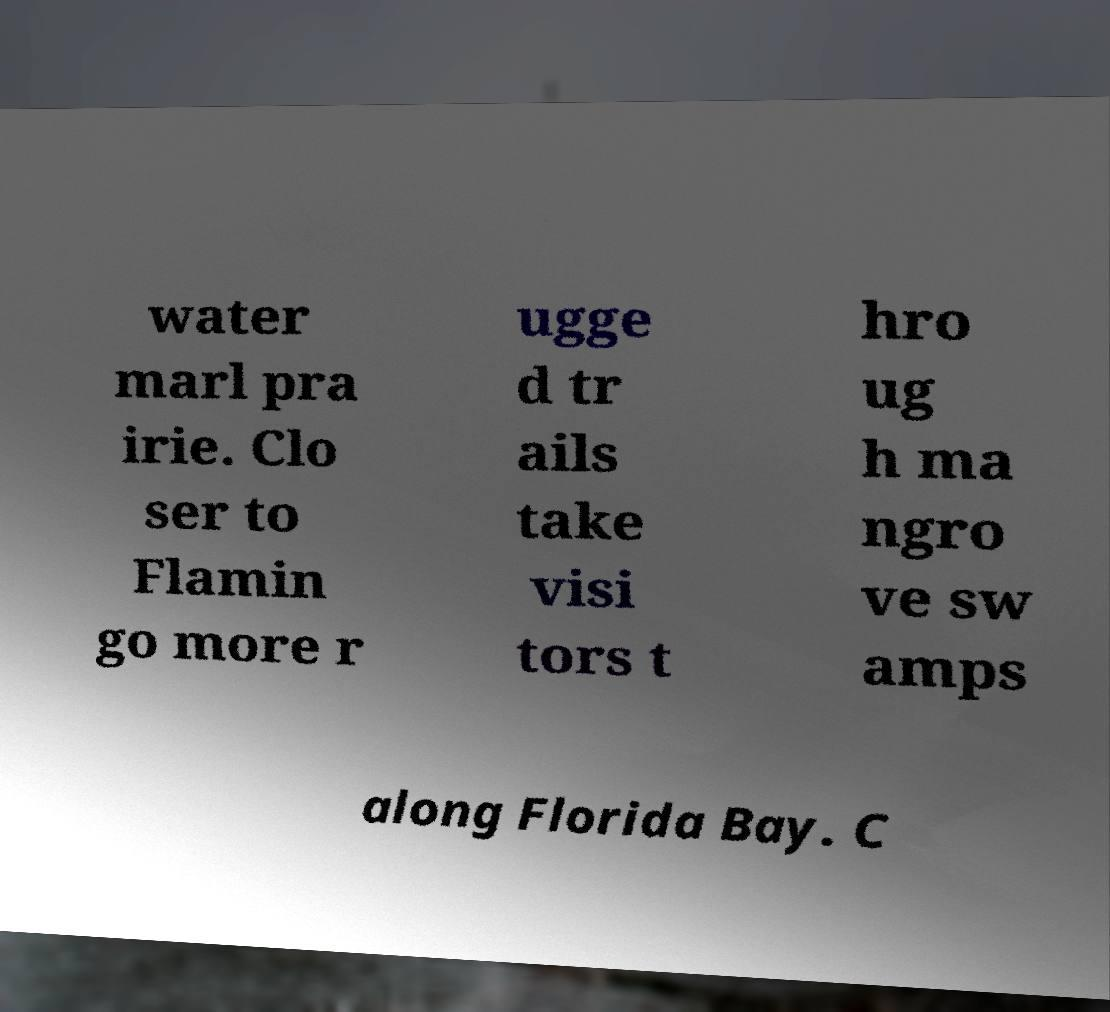Please read and relay the text visible in this image. What does it say? water marl pra irie. Clo ser to Flamin go more r ugge d tr ails take visi tors t hro ug h ma ngro ve sw amps along Florida Bay. C 